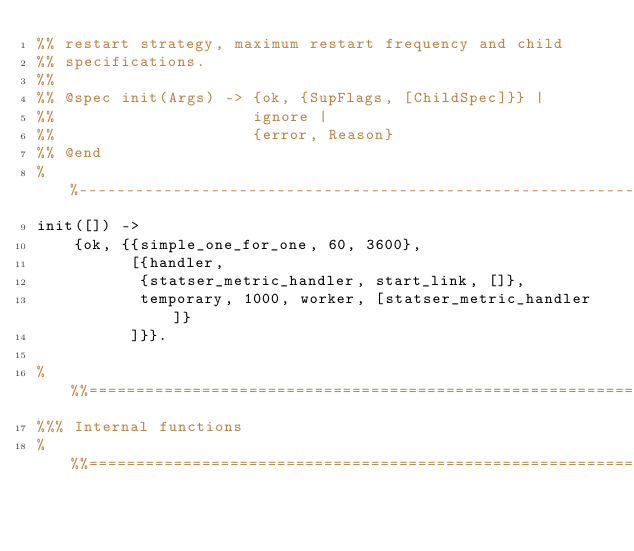Convert code to text. <code><loc_0><loc_0><loc_500><loc_500><_Erlang_>%% restart strategy, maximum restart frequency and child
%% specifications.
%%
%% @spec init(Args) -> {ok, {SupFlags, [ChildSpec]}} |
%%                     ignore |
%%                     {error, Reason}
%% @end
%%--------------------------------------------------------------------
init([]) ->
    {ok, {{simple_one_for_one, 60, 3600},
          [{handler,
           {statser_metric_handler, start_link, []},
           temporary, 1000, worker, [statser_metric_handler]}
          ]}}.

%%%===================================================================
%%% Internal functions
%%%===================================================================
</code> 